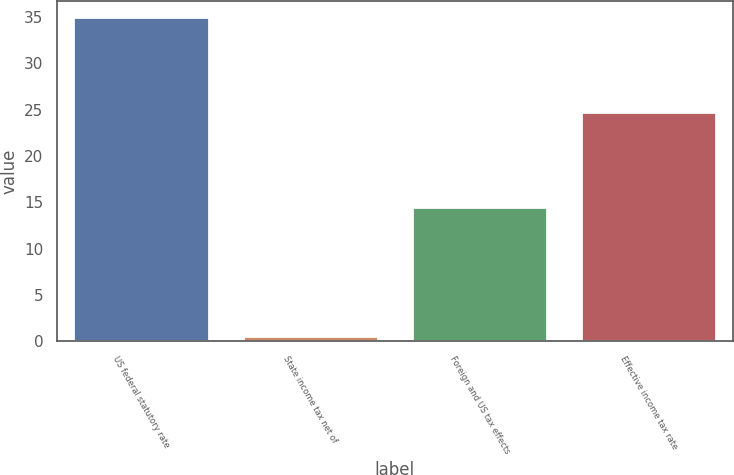<chart> <loc_0><loc_0><loc_500><loc_500><bar_chart><fcel>US federal statutory rate<fcel>State income tax net of<fcel>Foreign and US tax effects<fcel>Effective income tax rate<nl><fcel>35<fcel>0.6<fcel>14.5<fcel>24.7<nl></chart> 